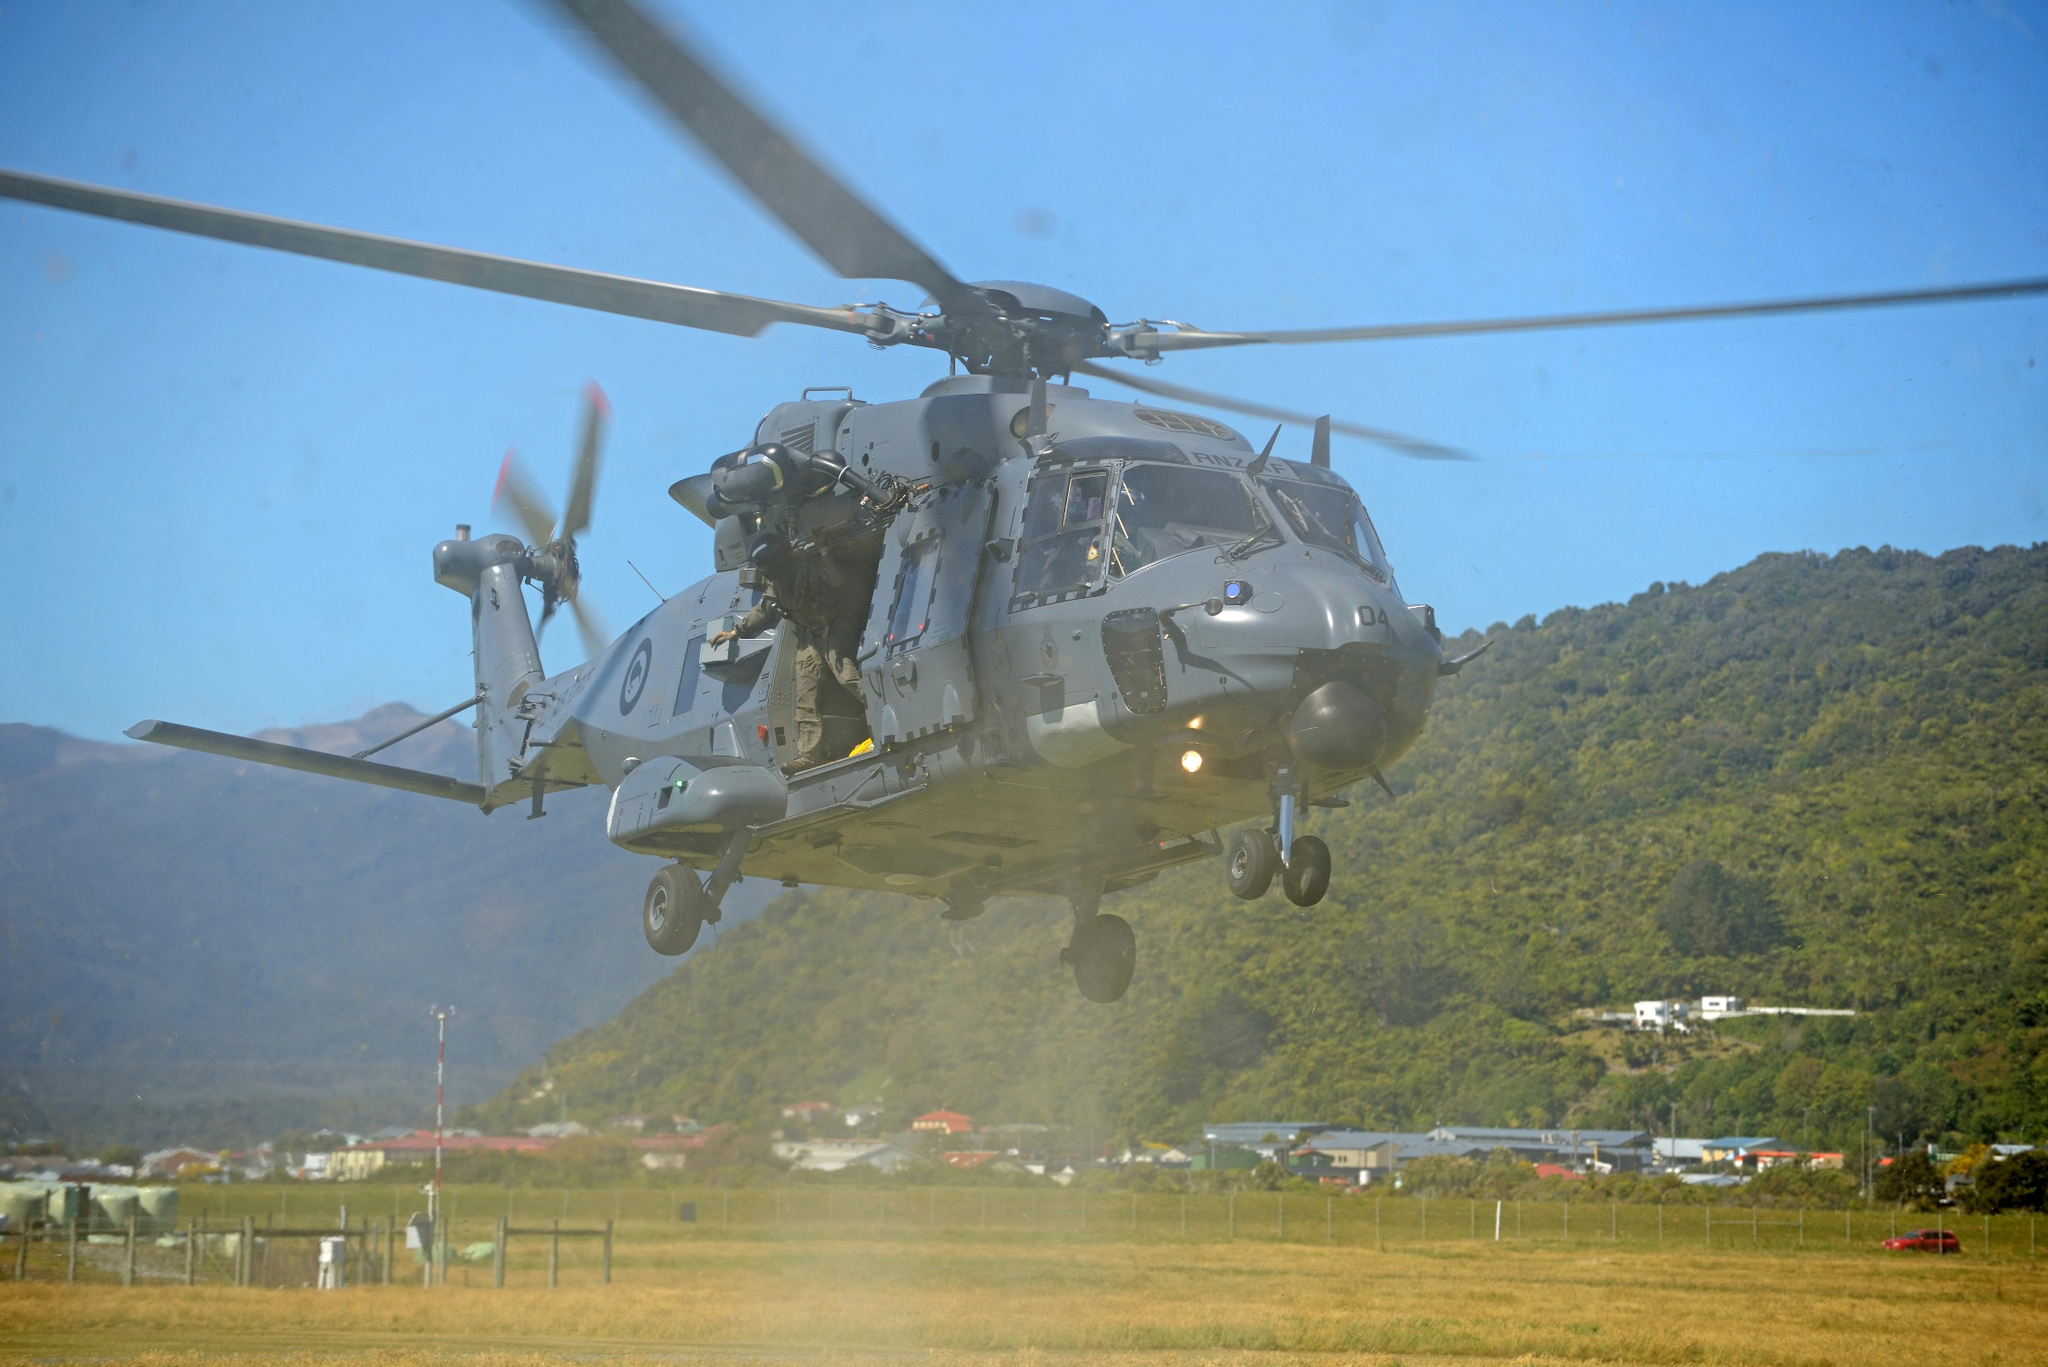Describe the atmosphere of the area around the helicopter in one sentence. The area around the helicopter exudes an intense, vibrant atmosphere, blending the robust energy of a powerful aircraft with the serene, untouched beauty of the expansive green field and distant, misty mountains. 